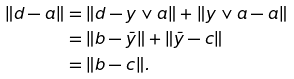Convert formula to latex. <formula><loc_0><loc_0><loc_500><loc_500>\| d - a \| & = \| d - y \vee a \| + \| y \vee a - a \| \\ & = \| b - \bar { y } \| + \| \bar { y } - c \| \\ & = \| b - c \| .</formula> 